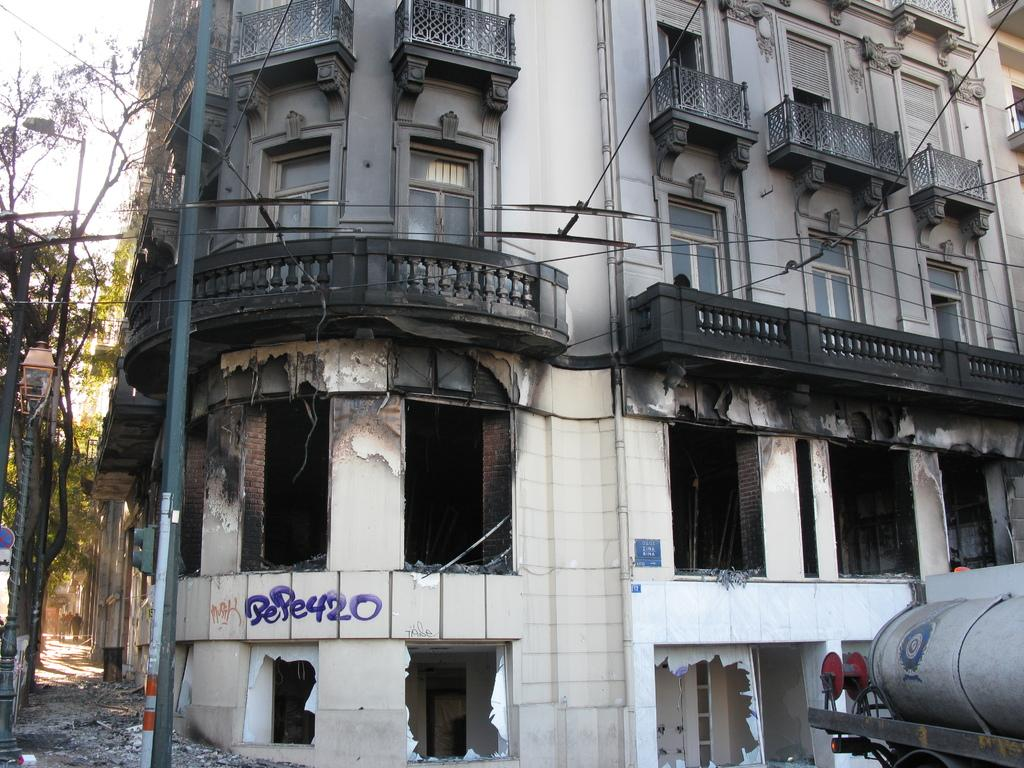What type of structure is depicted in the image? There is an old and broken building in the image. What can be seen on the path in the image? There is a pole on the path in the image. What type of vegetation is visible in the image? There are trees visible in the image. What is visible in the background of the image? The sky is visible in the image. What language is the lawyer speaking to the sea in the image? There is no lawyer or sea present in the image, so this question cannot be answered. 